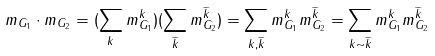<formula> <loc_0><loc_0><loc_500><loc_500>m _ { G _ { 1 } } \cdot m _ { G _ { 2 } } = ( \sum _ { k } m _ { G _ { 1 } } ^ { k } ) ( \sum _ { \widetilde { k } } m _ { G _ { 2 } } ^ { \widetilde { k } } ) = \sum _ { k , \widetilde { k } } m _ { G _ { 1 } } ^ { k } m _ { G _ { 2 } } ^ { \widetilde { k } } = \sum _ { k \sim \widetilde { k } } m _ { G _ { 1 } } ^ { k } m _ { G _ { 2 } } ^ { \widetilde { k } }</formula> 